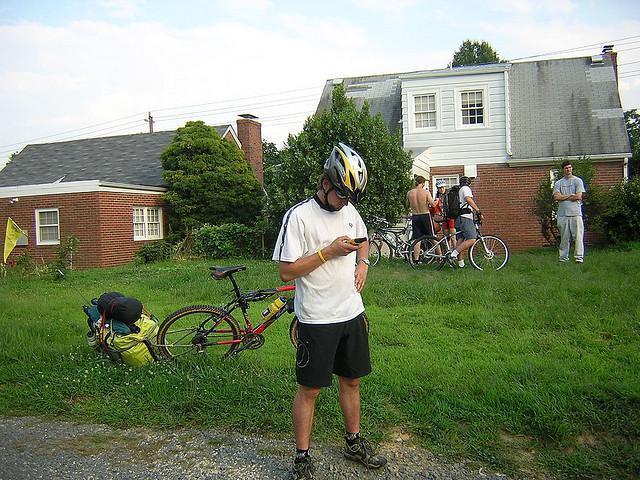Why is the man looking down at his hand?
Make your selection from the four choices given to correctly answer the question.
Options: Holding cash, see cut, answering phone, to eat. Answering phone. 